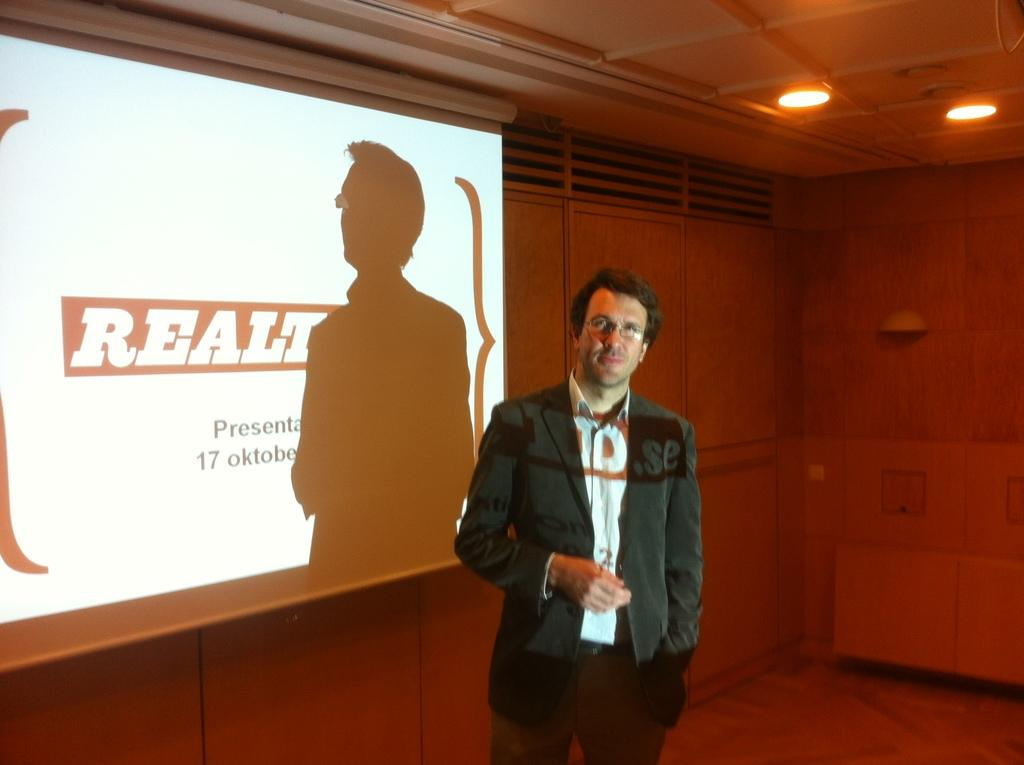What is the main subject of the image? There is a man standing in the image. What is located behind the man? There is a screen behind the man. What can be seen in the image that provides illumination? There are lights visible in the image. What type of architectural feature is present in the image? There are vents in the image. What color is the ink on the sock in the image? There is no sock or ink present in the image. 